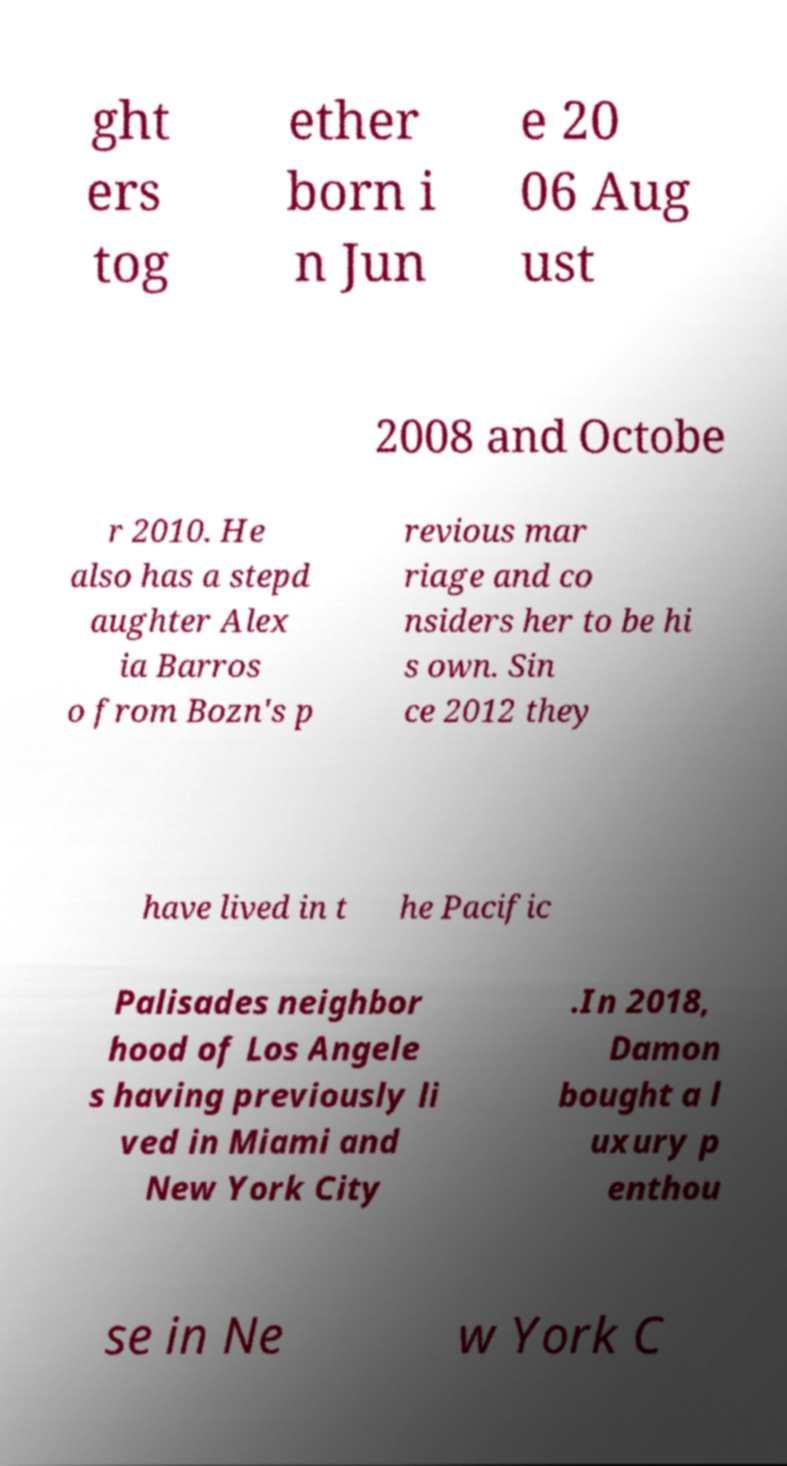Can you accurately transcribe the text from the provided image for me? ght ers tog ether born i n Jun e 20 06 Aug ust 2008 and Octobe r 2010. He also has a stepd aughter Alex ia Barros o from Bozn's p revious mar riage and co nsiders her to be hi s own. Sin ce 2012 they have lived in t he Pacific Palisades neighbor hood of Los Angele s having previously li ved in Miami and New York City .In 2018, Damon bought a l uxury p enthou se in Ne w York C 